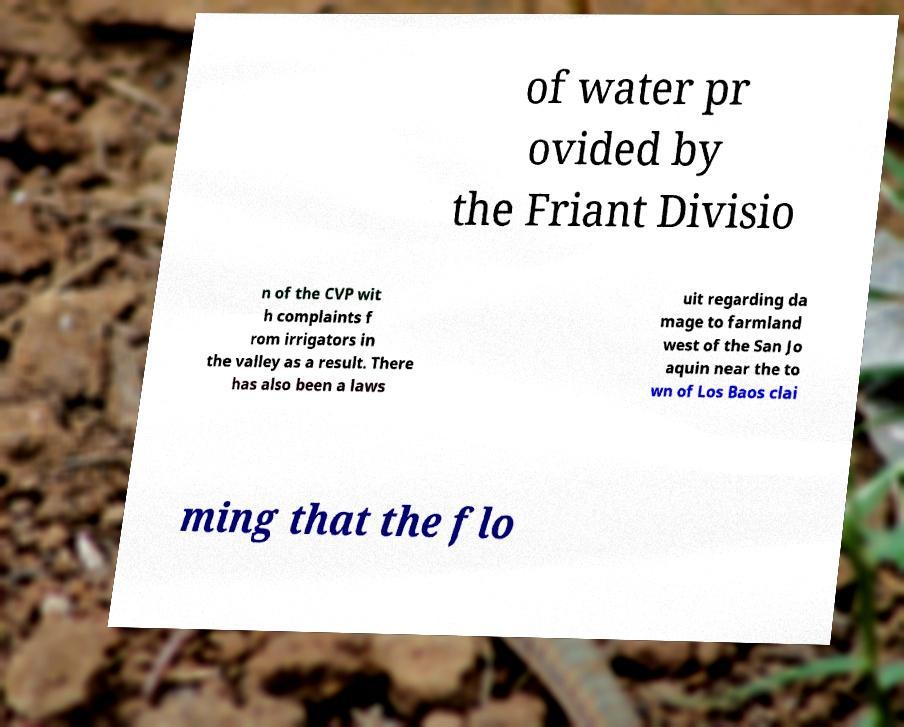Can you accurately transcribe the text from the provided image for me? of water pr ovided by the Friant Divisio n of the CVP wit h complaints f rom irrigators in the valley as a result. There has also been a laws uit regarding da mage to farmland west of the San Jo aquin near the to wn of Los Baos clai ming that the flo 